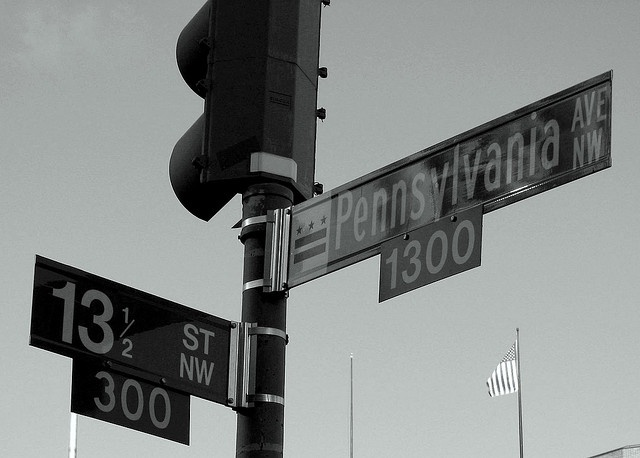Describe the objects in this image and their specific colors. I can see a traffic light in darkgray and black tones in this image. 